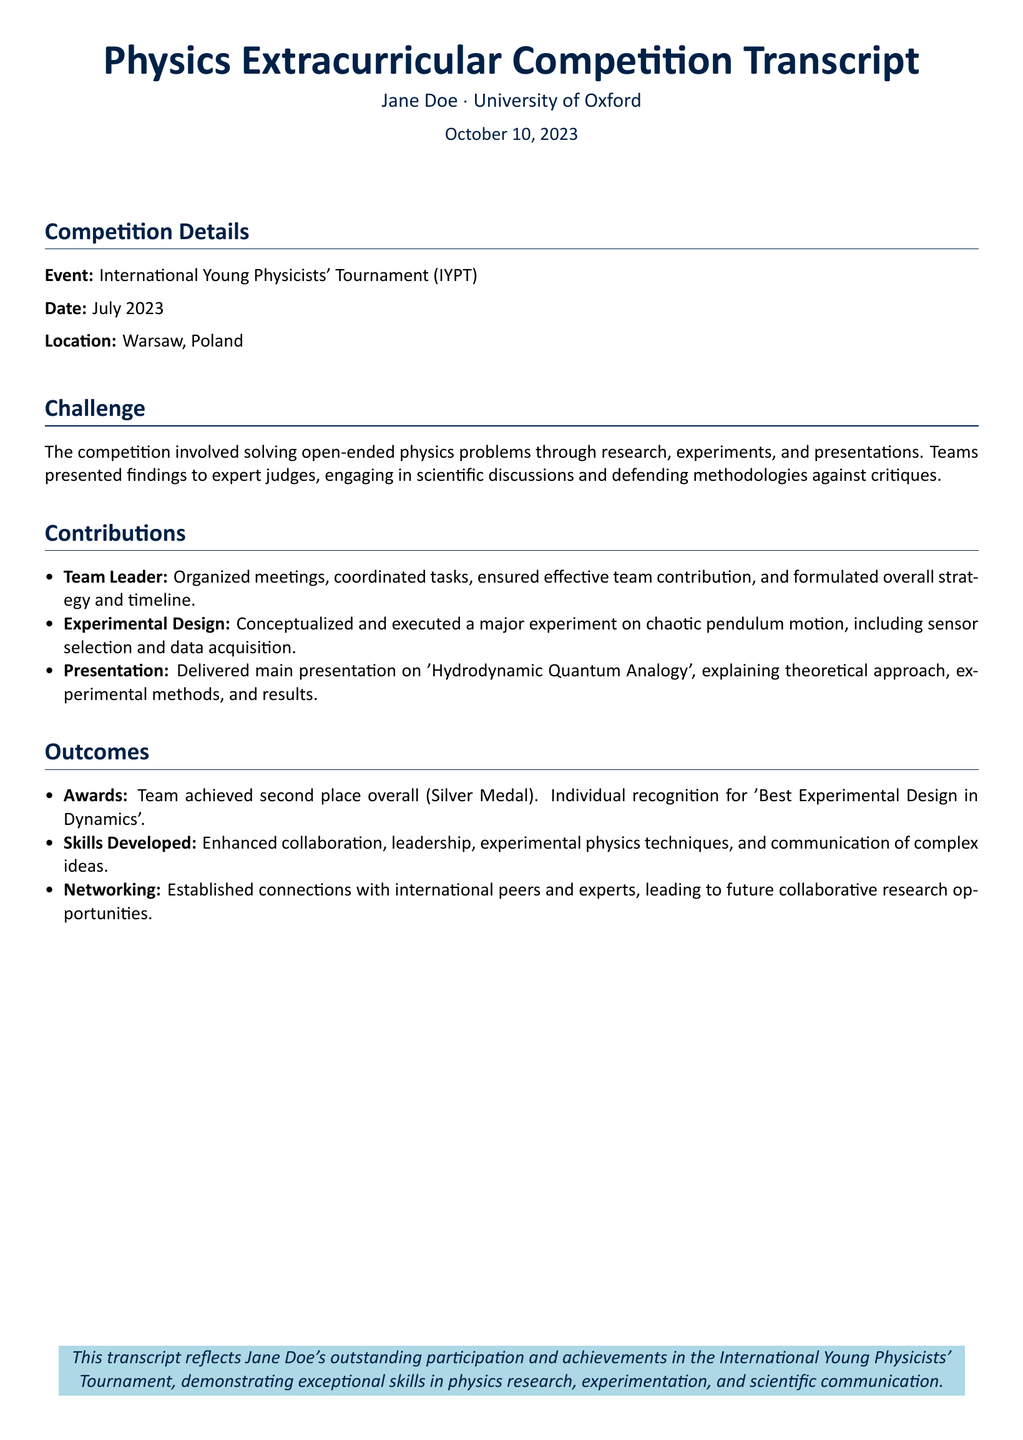What was the event? The event is specified at the beginning of the document under "Event".
Answer: International Young Physicists' Tournament (IYPT) When did the competition take place? The date of the event is listed under "Date".
Answer: July 2023 Where was the competition held? The location is mentioned in the "Location" section.
Answer: Warsaw, Poland What award did the team achieve? The outcomes section describes the team's achievement in terms of awards.
Answer: Silver Medal What was Jane Doe's main role in the team? The contributions section identifies her primary position.
Answer: Team Leader What was the main presentation topic? The topic of the main presentation is mentioned in the contributions section.
Answer: Hydrodynamic Quantum Analogy What skill was particularly enhanced during the competition? The "Skills Developed" section outlines specific skills gained.
Answer: Communication of complex ideas What was recognized as the best in the competition? The outcomes section includes specific recognition received by Jane Doe.
Answer: Best Experimental Design in Dynamics What type of problems did the competition involve? The challenge section describes the nature of the problems addressed in the competition.
Answer: Open-ended physics problems 